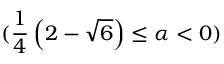<formula> <loc_0><loc_0><loc_500><loc_500>( \frac { 1 } { 4 } \left ( 2 - \sqrt { 6 } \right ) \leq \alpha < 0 )</formula> 